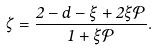Convert formula to latex. <formula><loc_0><loc_0><loc_500><loc_500>\zeta = \frac { 2 - d - \xi + 2 \xi \mathcal { P } } { 1 + \xi \mathcal { P } } .</formula> 